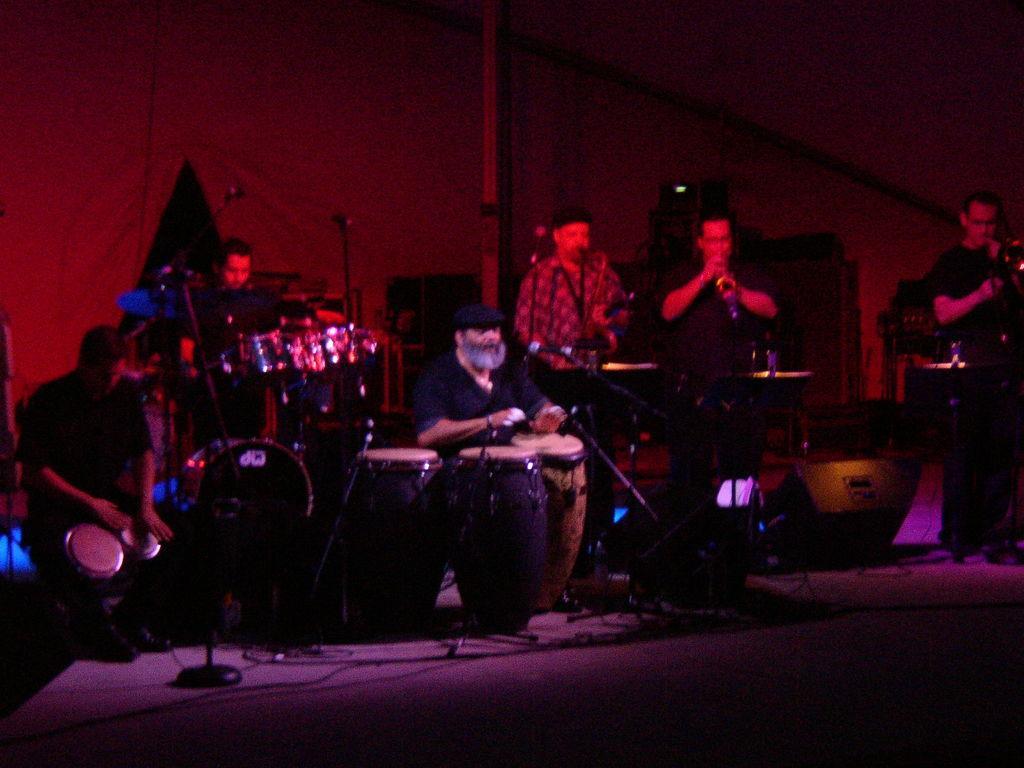Could you give a brief overview of what you see in this image? In this picture we can see some paper in standing position and some are in sitting position they all are playing a musical instruments one person is is carrying a microphone he is singing a song. 